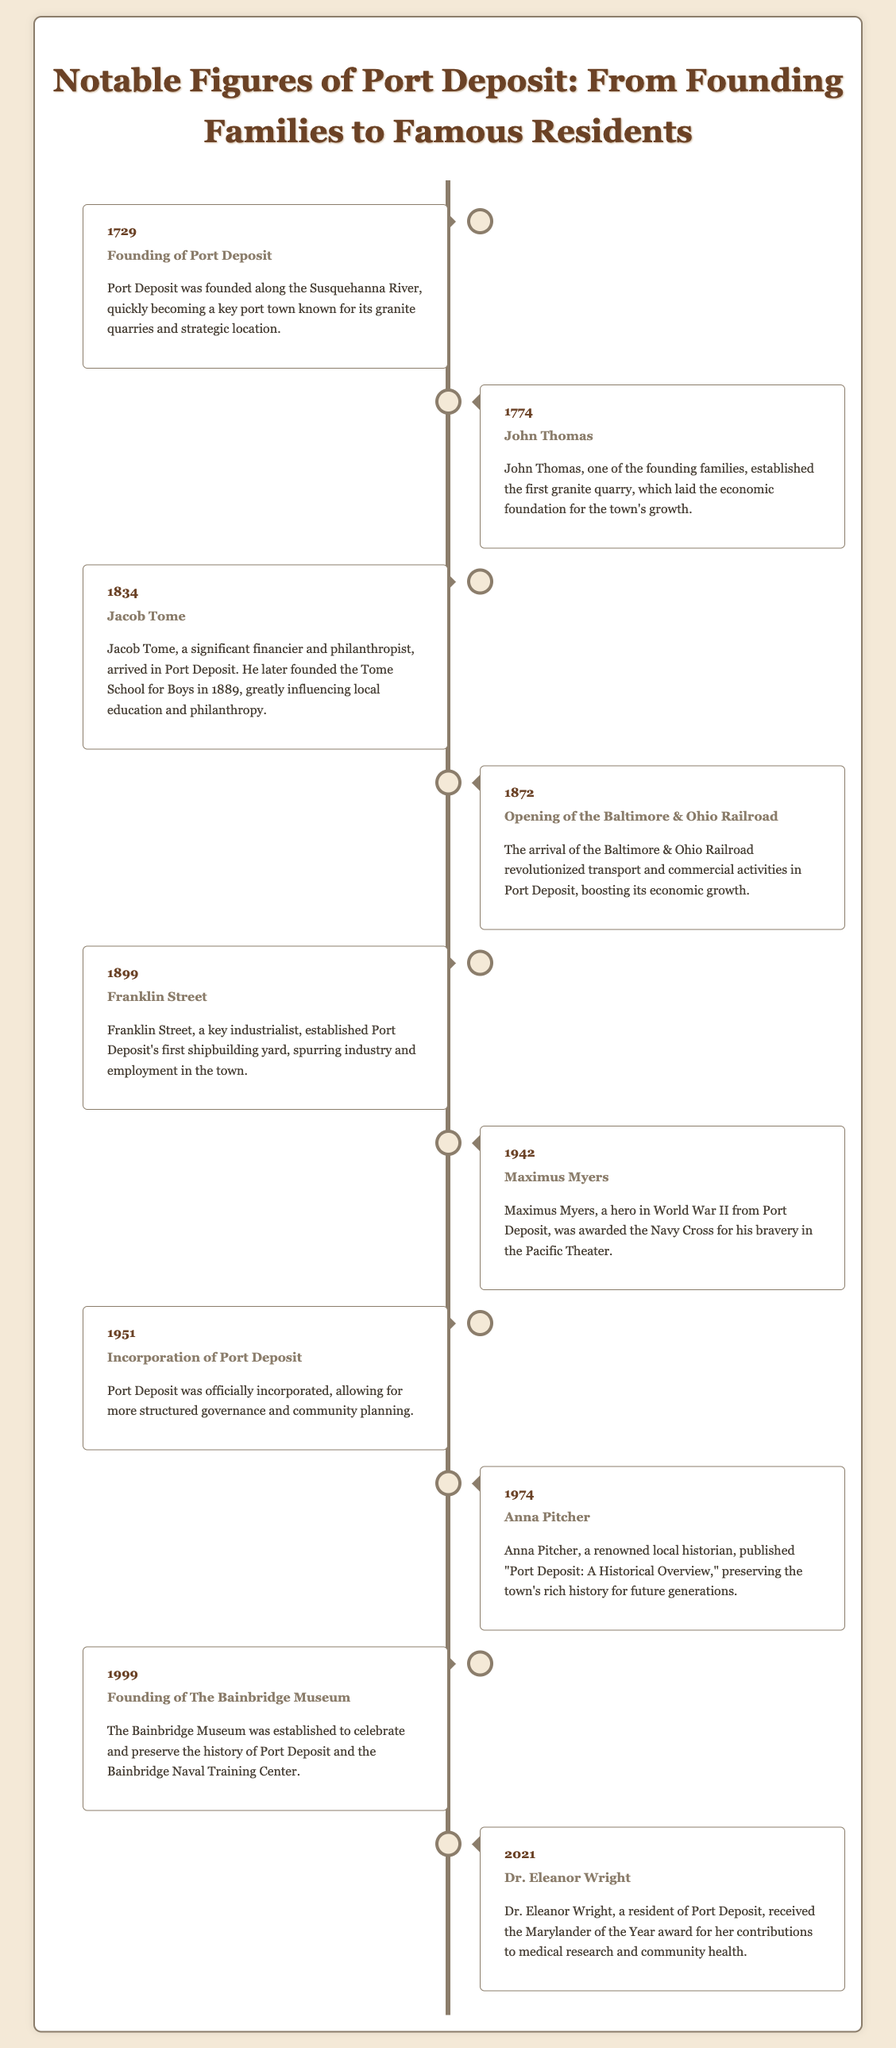What year was Port Deposit founded? Port Deposit was founded in 1729, as indicated in the timeline.
Answer: 1729 Who established the first granite quarry in Port Deposit? John Thomas is noted for establishing the first granite quarry in 1774.
Answer: John Thomas In what year was the Baltimore & Ohio Railroad opened? The timeline records the opening of the Baltimore & Ohio Railroad in 1872.
Answer: 1872 Which notable figure founded the Tome School for Boys? Jacob Tome, arriving in 1834, is credited with founding the Tome School for Boys.
Answer: Jacob Tome What significant event took place in Port Deposit in 1951? The incorporation of Port Deposit occurred in 1951, noted in the timeline.
Answer: Incorporation of Port Deposit How many years passed between the founding of Port Deposit and the establishment of the Bainbridge Museum? The Bainbridge Museum was founded in 1999, so the difference from 1729 to 1999 is 270 years.
Answer: 270 years Who published "Port Deposit: A Historical Overview"? The local historian Anna Pitcher published this work in 1974.
Answer: Anna Pitcher What award did Dr. Eleanor Wright receive in 2021? Dr. Eleanor Wright was recognized as the Marylander of the Year in 2021.
Answer: Marylander of the Year What was the first notable industrial project in Port Deposit? The first shipbuilding yard, established by Franklin Street in 1899, was key to local industry.
Answer: First shipbuilding yard 